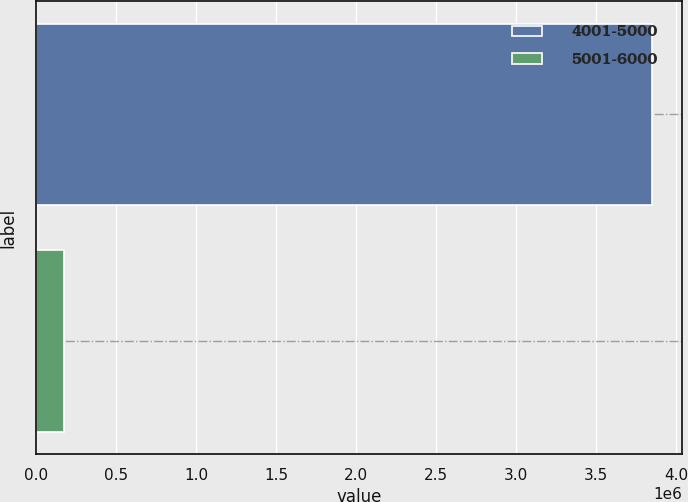<chart> <loc_0><loc_0><loc_500><loc_500><bar_chart><fcel>4001-5000<fcel>5001-6000<nl><fcel>3.84444e+06<fcel>169575<nl></chart> 